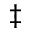Convert formula to latex. <formula><loc_0><loc_0><loc_500><loc_500>^ { \ddagger }</formula> 